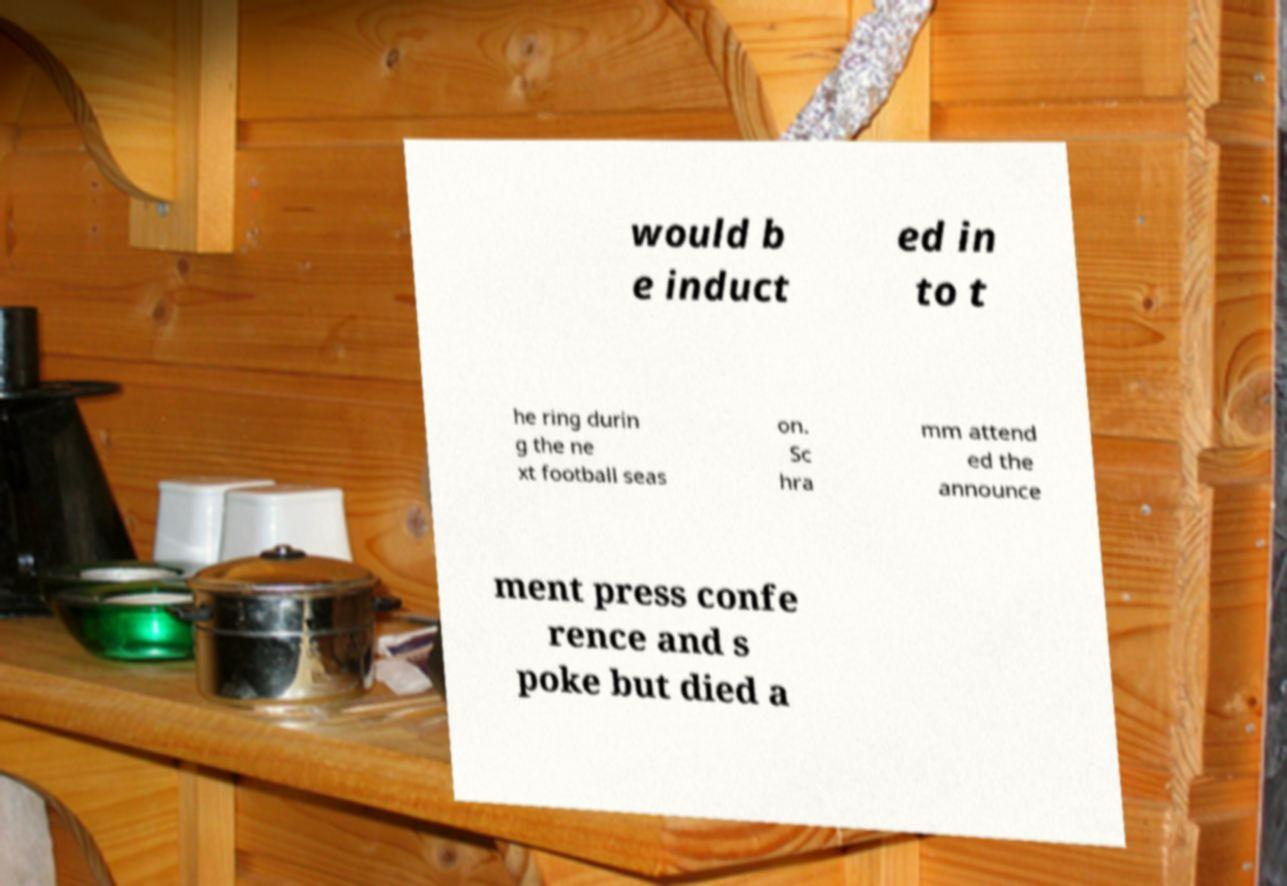I need the written content from this picture converted into text. Can you do that? would b e induct ed in to t he ring durin g the ne xt football seas on. Sc hra mm attend ed the announce ment press confe rence and s poke but died a 